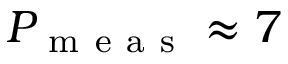<formula> <loc_0><loc_0><loc_500><loc_500>P _ { m e a s } \approx 7</formula> 